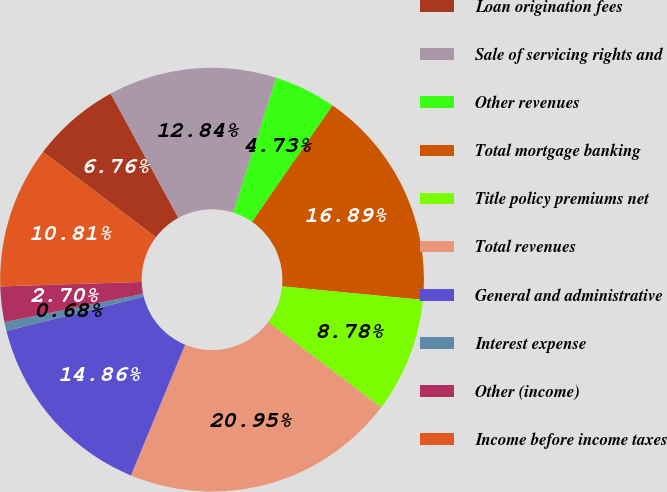Convert chart to OTSL. <chart><loc_0><loc_0><loc_500><loc_500><pie_chart><fcel>Loan origination fees<fcel>Sale of servicing rights and<fcel>Other revenues<fcel>Total mortgage banking<fcel>Title policy premiums net<fcel>Total revenues<fcel>General and administrative<fcel>Interest expense<fcel>Other (income)<fcel>Income before income taxes<nl><fcel>6.76%<fcel>12.84%<fcel>4.73%<fcel>16.89%<fcel>8.78%<fcel>20.95%<fcel>14.86%<fcel>0.68%<fcel>2.7%<fcel>10.81%<nl></chart> 